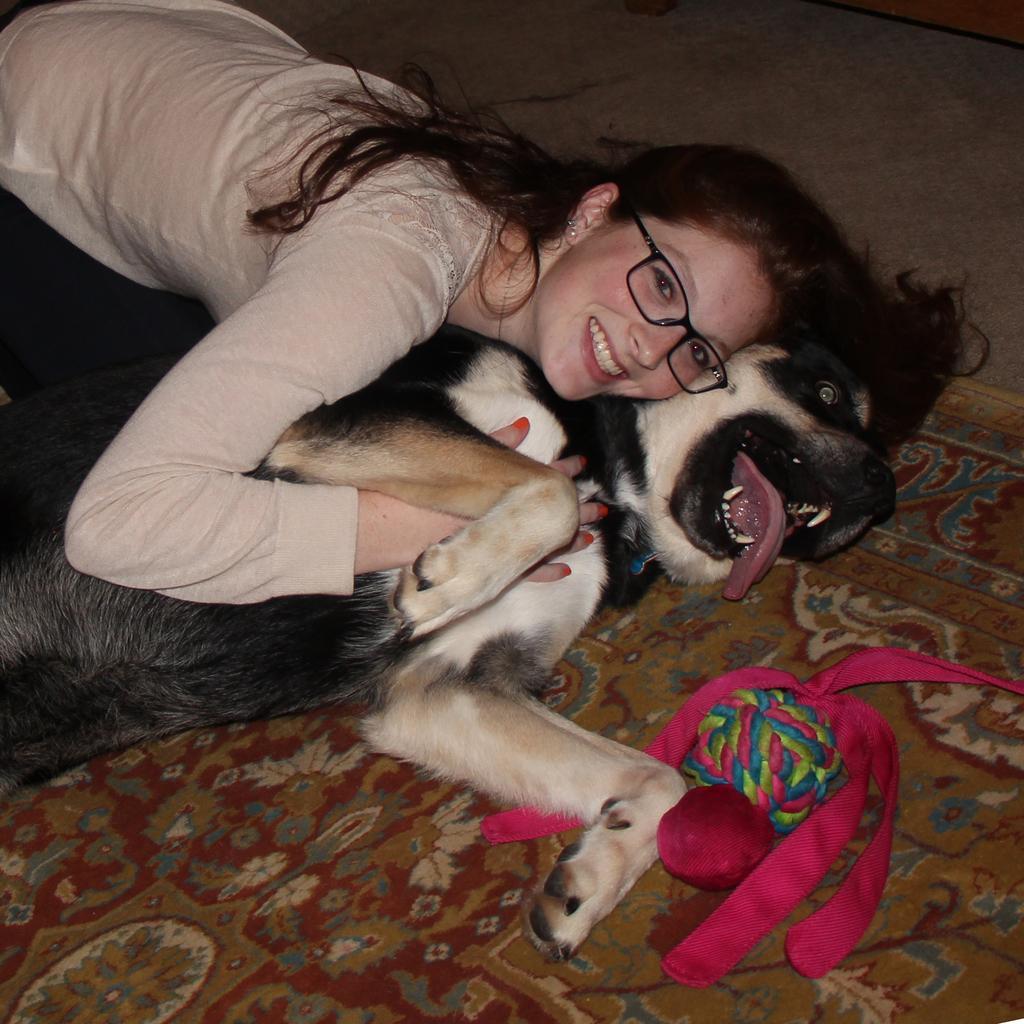In one or two sentences, can you explain what this image depicts? In this image, we can see a person on the dog which is on the carpet. This person is wearing clothes and spectacles. There is an object in the bottom right of the image. 